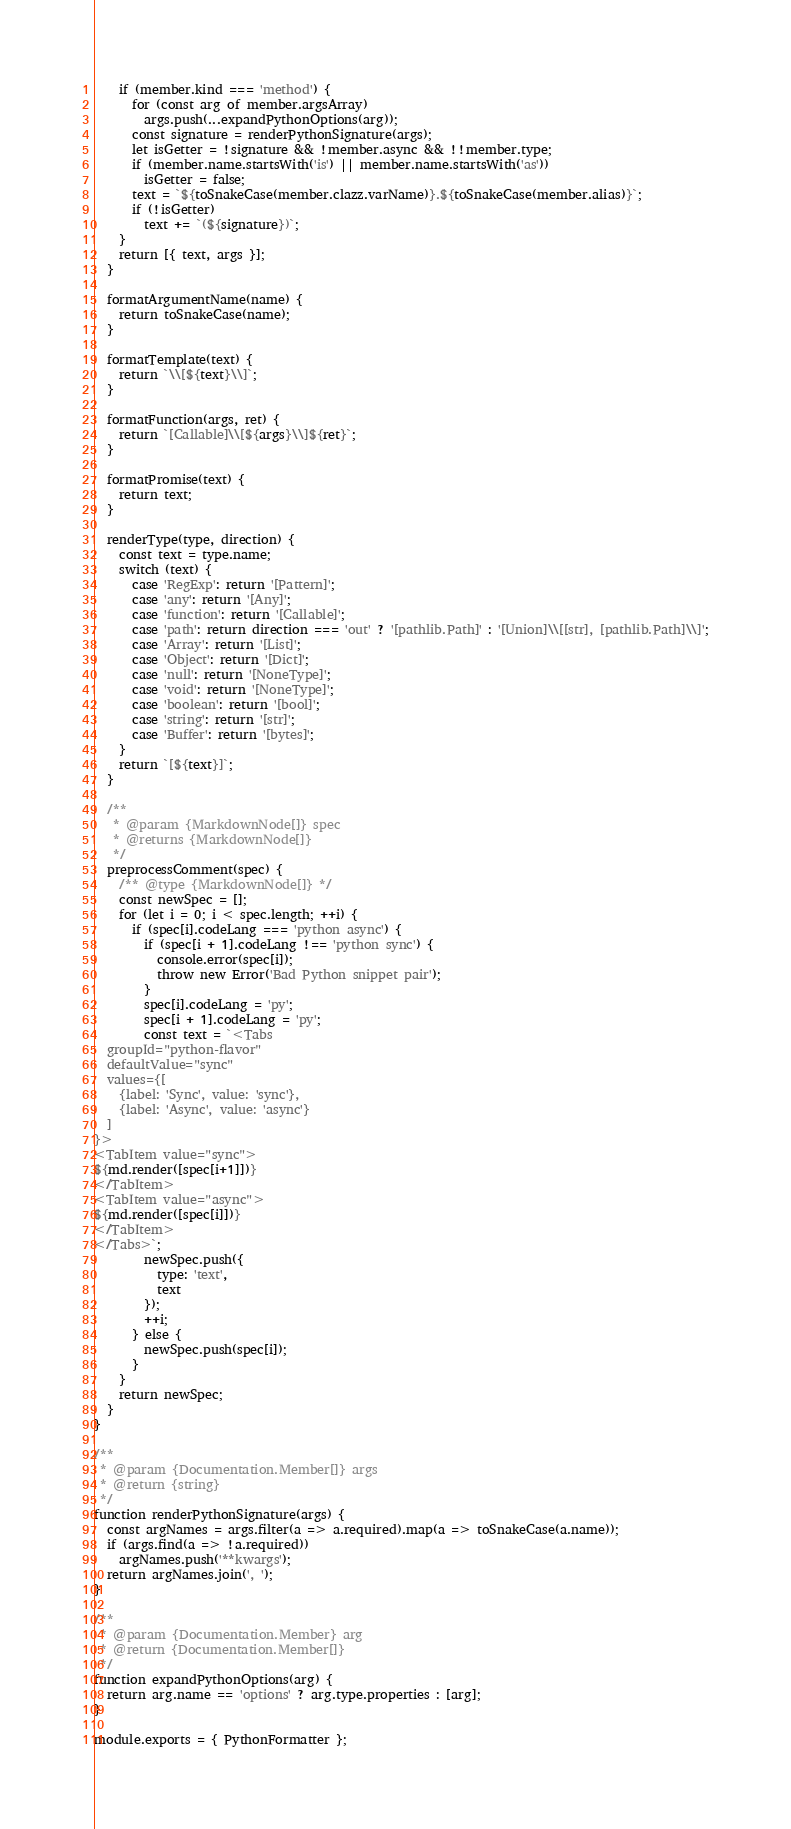Convert code to text. <code><loc_0><loc_0><loc_500><loc_500><_JavaScript_>    if (member.kind === 'method') {
      for (const arg of member.argsArray)
        args.push(...expandPythonOptions(arg));
      const signature = renderPythonSignature(args);
      let isGetter = !signature && !member.async && !!member.type;
      if (member.name.startsWith('is') || member.name.startsWith('as'))
        isGetter = false;
      text = `${toSnakeCase(member.clazz.varName)}.${toSnakeCase(member.alias)}`;
      if (!isGetter)
        text += `(${signature})`;
    }
    return [{ text, args }];
  }

  formatArgumentName(name) {
    return toSnakeCase(name);
  }

  formatTemplate(text) {
    return `\\[${text}\\]`;
  }

  formatFunction(args, ret) {
    return `[Callable]\\[${args}\\]${ret}`;
  }

  formatPromise(text) {
    return text;
  }

  renderType(type, direction) {
    const text = type.name;
    switch (text) {
      case 'RegExp': return '[Pattern]';
      case 'any': return '[Any]';
      case 'function': return '[Callable]';
      case 'path': return direction === 'out' ? '[pathlib.Path]' : '[Union]\\[[str], [pathlib.Path]\\]';
      case 'Array': return '[List]';
      case 'Object': return '[Dict]';
      case 'null': return '[NoneType]';
      case 'void': return '[NoneType]';
      case 'boolean': return '[bool]';
      case 'string': return '[str]';
      case 'Buffer': return '[bytes]';
    }
    return `[${text}]`;
  }

  /**
   * @param {MarkdownNode[]} spec
   * @returns {MarkdownNode[]}
   */
  preprocessComment(spec) {
    /** @type {MarkdownNode[]} */
    const newSpec = [];
    for (let i = 0; i < spec.length; ++i) {
      if (spec[i].codeLang === 'python async') {
        if (spec[i + 1].codeLang !== 'python sync') {
          console.error(spec[i]);
          throw new Error('Bad Python snippet pair');
        }
        spec[i].codeLang = 'py';
        spec[i + 1].codeLang = 'py';
        const text = `<Tabs
  groupId="python-flavor"
  defaultValue="sync"
  values={[
    {label: 'Sync', value: 'sync'},
    {label: 'Async', value: 'async'}
  ]
}>
<TabItem value="sync">
${md.render([spec[i+1]])}
</TabItem>
<TabItem value="async">
${md.render([spec[i]])}
</TabItem>
</Tabs>`;
        newSpec.push({
          type: 'text',
          text
        });
        ++i;
      } else {
        newSpec.push(spec[i]);
      }
    }
    return newSpec;
  }
}

/**
 * @param {Documentation.Member[]} args
 * @return {string}
 */
function renderPythonSignature(args) {
  const argNames = args.filter(a => a.required).map(a => toSnakeCase(a.name));
  if (args.find(a => !a.required))
    argNames.push('**kwargs');
  return argNames.join(', ');
}

/**
 * @param {Documentation.Member} arg
 * @return {Documentation.Member[]}
 */
function expandPythonOptions(arg) {
  return arg.name == 'options' ? arg.type.properties : [arg];
}

module.exports = { PythonFormatter };
</code> 